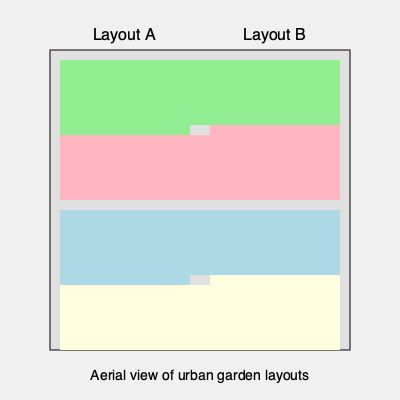As an environmental lawyer focused on sustainable living, which of the two urban garden layouts (A or B) would you recommend for maximizing sunlight exposure and minimizing water usage in a densely populated area? To determine the most efficient layout for a sustainable urban garden, we need to consider several factors:

1. Sunlight exposure:
   - Layout A: Square plots allow for more even sunlight distribution throughout the day.
   - Layout B: Long, narrow plots may lead to shading issues, especially in densely populated areas with tall buildings.

2. Water usage:
   - Layout A: Compact square plots minimize exposed soil surface, reducing water evaporation.
   - Layout B: Long, narrow plots have more exposed soil surface, potentially increasing water evaporation.

3. Space efficiency:
   - Both layouts utilize the same total area, but Layout A offers better accessibility and easier maintenance.

4. Crop diversity:
   - Layout A: Separate plots allow for better crop rotation and diverse planting.
   - Layout B: Long strips may limit crop diversity and make rotation more challenging.

5. Microclimate creation:
   - Layout A: Square plots create distinct microclimates, beneficial for different plant types.
   - Layout B: Less variation in microclimates due to uniform layout.

6. Irrigation efficiency:
   - Layout A: Easier to implement efficient drip irrigation systems in square plots.
   - Layout B: May require longer irrigation lines, potentially leading to water pressure issues.

7. Urban heat island mitigation:
   - Layout A: Better distribution of green spaces, more effective in reducing urban heat island effect.
   - Layout B: Less effective in creating cooler microclimates due to linear arrangement.

Considering these factors, Layout A provides better sunlight exposure, more efficient water usage, and greater flexibility for sustainable urban gardening practices.
Answer: Layout A 